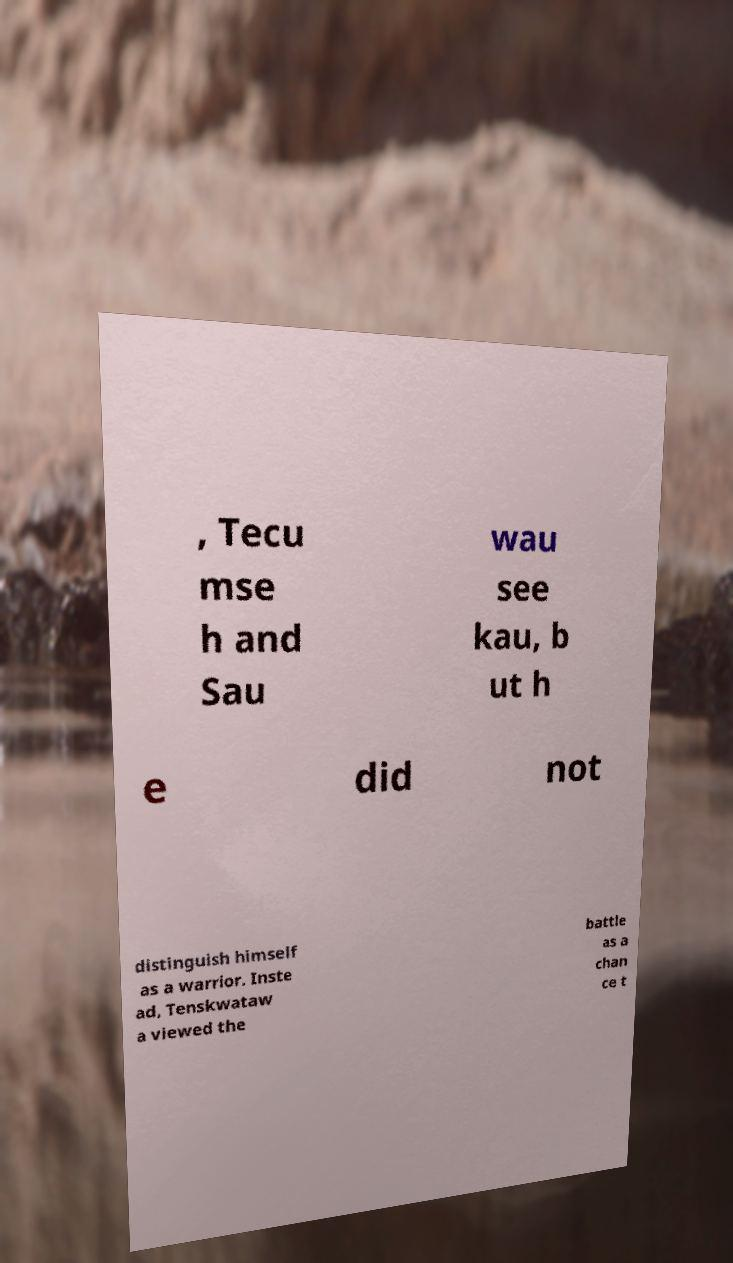Can you read and provide the text displayed in the image?This photo seems to have some interesting text. Can you extract and type it out for me? , Tecu mse h and Sau wau see kau, b ut h e did not distinguish himself as a warrior. Inste ad, Tenskwataw a viewed the battle as a chan ce t 